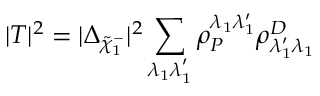<formula> <loc_0><loc_0><loc_500><loc_500>| T | ^ { 2 } = | \Delta _ { \tilde { \chi } _ { 1 } ^ { - } } | ^ { 2 } \sum _ { \lambda _ { 1 } \lambda _ { 1 } ^ { ^ { \prime } } } \rho _ { P } ^ { \lambda _ { 1 } \lambda _ { 1 } ^ { \prime } } \rho _ { \lambda _ { 1 } ^ { \prime } \lambda _ { 1 } } ^ { D }</formula> 